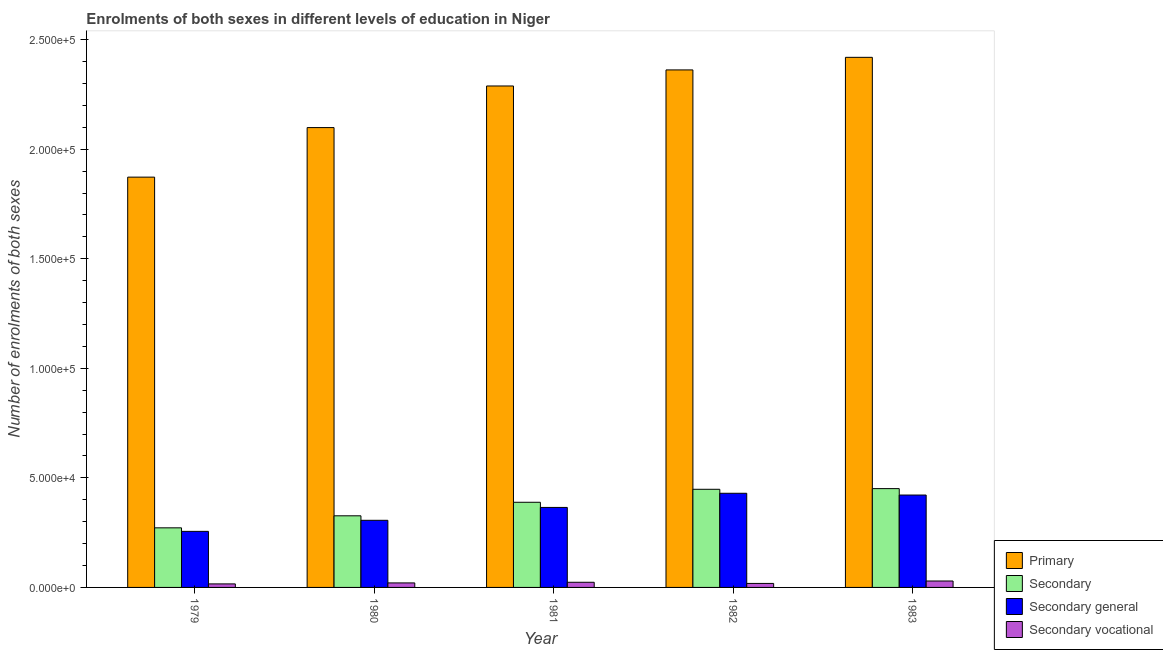How many different coloured bars are there?
Give a very brief answer. 4. How many bars are there on the 5th tick from the left?
Offer a terse response. 4. How many bars are there on the 1st tick from the right?
Make the answer very short. 4. What is the label of the 1st group of bars from the left?
Offer a very short reply. 1979. What is the number of enrolments in primary education in 1983?
Your answer should be very brief. 2.42e+05. Across all years, what is the maximum number of enrolments in secondary general education?
Provide a succinct answer. 4.30e+04. Across all years, what is the minimum number of enrolments in secondary vocational education?
Your response must be concise. 1613. In which year was the number of enrolments in secondary general education minimum?
Provide a short and direct response. 1979. What is the total number of enrolments in primary education in the graph?
Keep it short and to the point. 1.10e+06. What is the difference between the number of enrolments in primary education in 1980 and that in 1981?
Keep it short and to the point. -1.90e+04. What is the difference between the number of enrolments in primary education in 1983 and the number of enrolments in secondary vocational education in 1980?
Your answer should be very brief. 3.21e+04. What is the average number of enrolments in secondary general education per year?
Offer a very short reply. 3.56e+04. What is the ratio of the number of enrolments in secondary general education in 1980 to that in 1981?
Keep it short and to the point. 0.84. Is the number of enrolments in secondary general education in 1980 less than that in 1982?
Ensure brevity in your answer.  Yes. What is the difference between the highest and the second highest number of enrolments in secondary general education?
Your answer should be compact. 803. What is the difference between the highest and the lowest number of enrolments in secondary education?
Make the answer very short. 1.79e+04. In how many years, is the number of enrolments in secondary education greater than the average number of enrolments in secondary education taken over all years?
Make the answer very short. 3. Is it the case that in every year, the sum of the number of enrolments in secondary vocational education and number of enrolments in secondary general education is greater than the sum of number of enrolments in primary education and number of enrolments in secondary education?
Keep it short and to the point. No. What does the 3rd bar from the left in 1981 represents?
Offer a very short reply. Secondary general. What does the 1st bar from the right in 1983 represents?
Give a very brief answer. Secondary vocational. How many years are there in the graph?
Offer a terse response. 5. Does the graph contain any zero values?
Provide a succinct answer. No. What is the title of the graph?
Offer a very short reply. Enrolments of both sexes in different levels of education in Niger. What is the label or title of the Y-axis?
Your response must be concise. Number of enrolments of both sexes. What is the Number of enrolments of both sexes of Primary in 1979?
Keep it short and to the point. 1.87e+05. What is the Number of enrolments of both sexes of Secondary in 1979?
Make the answer very short. 2.72e+04. What is the Number of enrolments of both sexes in Secondary general in 1979?
Keep it short and to the point. 2.56e+04. What is the Number of enrolments of both sexes of Secondary vocational in 1979?
Give a very brief answer. 1613. What is the Number of enrolments of both sexes of Primary in 1980?
Your response must be concise. 2.10e+05. What is the Number of enrolments of both sexes of Secondary in 1980?
Your response must be concise. 3.27e+04. What is the Number of enrolments of both sexes in Secondary general in 1980?
Your response must be concise. 3.06e+04. What is the Number of enrolments of both sexes of Secondary vocational in 1980?
Your answer should be very brief. 2057. What is the Number of enrolments of both sexes of Primary in 1981?
Your answer should be very brief. 2.29e+05. What is the Number of enrolments of both sexes in Secondary in 1981?
Offer a very short reply. 3.89e+04. What is the Number of enrolments of both sexes in Secondary general in 1981?
Offer a terse response. 3.65e+04. What is the Number of enrolments of both sexes in Secondary vocational in 1981?
Give a very brief answer. 2351. What is the Number of enrolments of both sexes in Primary in 1982?
Provide a short and direct response. 2.36e+05. What is the Number of enrolments of both sexes of Secondary in 1982?
Keep it short and to the point. 4.48e+04. What is the Number of enrolments of both sexes of Secondary general in 1982?
Provide a short and direct response. 4.30e+04. What is the Number of enrolments of both sexes of Secondary vocational in 1982?
Keep it short and to the point. 1821. What is the Number of enrolments of both sexes of Primary in 1983?
Offer a very short reply. 2.42e+05. What is the Number of enrolments of both sexes in Secondary in 1983?
Provide a short and direct response. 4.51e+04. What is the Number of enrolments of both sexes in Secondary general in 1983?
Your answer should be very brief. 4.22e+04. What is the Number of enrolments of both sexes of Secondary vocational in 1983?
Provide a succinct answer. 2930. Across all years, what is the maximum Number of enrolments of both sexes of Primary?
Offer a terse response. 2.42e+05. Across all years, what is the maximum Number of enrolments of both sexes in Secondary?
Your answer should be compact. 4.51e+04. Across all years, what is the maximum Number of enrolments of both sexes of Secondary general?
Make the answer very short. 4.30e+04. Across all years, what is the maximum Number of enrolments of both sexes in Secondary vocational?
Make the answer very short. 2930. Across all years, what is the minimum Number of enrolments of both sexes of Primary?
Offer a very short reply. 1.87e+05. Across all years, what is the minimum Number of enrolments of both sexes in Secondary?
Your response must be concise. 2.72e+04. Across all years, what is the minimum Number of enrolments of both sexes in Secondary general?
Give a very brief answer. 2.56e+04. Across all years, what is the minimum Number of enrolments of both sexes in Secondary vocational?
Provide a succinct answer. 1613. What is the total Number of enrolments of both sexes of Primary in the graph?
Your answer should be compact. 1.10e+06. What is the total Number of enrolments of both sexes of Secondary in the graph?
Provide a succinct answer. 1.89e+05. What is the total Number of enrolments of both sexes in Secondary general in the graph?
Keep it short and to the point. 1.78e+05. What is the total Number of enrolments of both sexes of Secondary vocational in the graph?
Ensure brevity in your answer.  1.08e+04. What is the difference between the Number of enrolments of both sexes of Primary in 1979 and that in 1980?
Offer a terse response. -2.26e+04. What is the difference between the Number of enrolments of both sexes of Secondary in 1979 and that in 1980?
Provide a succinct answer. -5491. What is the difference between the Number of enrolments of both sexes of Secondary general in 1979 and that in 1980?
Make the answer very short. -5047. What is the difference between the Number of enrolments of both sexes of Secondary vocational in 1979 and that in 1980?
Your answer should be compact. -444. What is the difference between the Number of enrolments of both sexes in Primary in 1979 and that in 1981?
Your answer should be compact. -4.16e+04. What is the difference between the Number of enrolments of both sexes in Secondary in 1979 and that in 1981?
Your answer should be compact. -1.17e+04. What is the difference between the Number of enrolments of both sexes in Secondary general in 1979 and that in 1981?
Make the answer very short. -1.09e+04. What is the difference between the Number of enrolments of both sexes in Secondary vocational in 1979 and that in 1981?
Your answer should be compact. -738. What is the difference between the Number of enrolments of both sexes in Primary in 1979 and that in 1982?
Your answer should be compact. -4.89e+04. What is the difference between the Number of enrolments of both sexes of Secondary in 1979 and that in 1982?
Offer a very short reply. -1.76e+04. What is the difference between the Number of enrolments of both sexes in Secondary general in 1979 and that in 1982?
Provide a short and direct response. -1.74e+04. What is the difference between the Number of enrolments of both sexes of Secondary vocational in 1979 and that in 1982?
Ensure brevity in your answer.  -208. What is the difference between the Number of enrolments of both sexes in Primary in 1979 and that in 1983?
Your response must be concise. -5.47e+04. What is the difference between the Number of enrolments of both sexes of Secondary in 1979 and that in 1983?
Provide a short and direct response. -1.79e+04. What is the difference between the Number of enrolments of both sexes of Secondary general in 1979 and that in 1983?
Make the answer very short. -1.66e+04. What is the difference between the Number of enrolments of both sexes of Secondary vocational in 1979 and that in 1983?
Your answer should be compact. -1317. What is the difference between the Number of enrolments of both sexes in Primary in 1980 and that in 1981?
Offer a terse response. -1.90e+04. What is the difference between the Number of enrolments of both sexes in Secondary in 1980 and that in 1981?
Your response must be concise. -6174. What is the difference between the Number of enrolments of both sexes in Secondary general in 1980 and that in 1981?
Provide a succinct answer. -5880. What is the difference between the Number of enrolments of both sexes in Secondary vocational in 1980 and that in 1981?
Your answer should be very brief. -294. What is the difference between the Number of enrolments of both sexes of Primary in 1980 and that in 1982?
Ensure brevity in your answer.  -2.63e+04. What is the difference between the Number of enrolments of both sexes in Secondary in 1980 and that in 1982?
Ensure brevity in your answer.  -1.21e+04. What is the difference between the Number of enrolments of both sexes in Secondary general in 1980 and that in 1982?
Keep it short and to the point. -1.23e+04. What is the difference between the Number of enrolments of both sexes of Secondary vocational in 1980 and that in 1982?
Give a very brief answer. 236. What is the difference between the Number of enrolments of both sexes in Primary in 1980 and that in 1983?
Your answer should be compact. -3.21e+04. What is the difference between the Number of enrolments of both sexes in Secondary in 1980 and that in 1983?
Give a very brief answer. -1.24e+04. What is the difference between the Number of enrolments of both sexes of Secondary general in 1980 and that in 1983?
Provide a short and direct response. -1.15e+04. What is the difference between the Number of enrolments of both sexes in Secondary vocational in 1980 and that in 1983?
Make the answer very short. -873. What is the difference between the Number of enrolments of both sexes of Primary in 1981 and that in 1982?
Keep it short and to the point. -7328. What is the difference between the Number of enrolments of both sexes of Secondary in 1981 and that in 1982?
Offer a very short reply. -5927. What is the difference between the Number of enrolments of both sexes in Secondary general in 1981 and that in 1982?
Your response must be concise. -6457. What is the difference between the Number of enrolments of both sexes in Secondary vocational in 1981 and that in 1982?
Give a very brief answer. 530. What is the difference between the Number of enrolments of both sexes in Primary in 1981 and that in 1983?
Make the answer very short. -1.31e+04. What is the difference between the Number of enrolments of both sexes of Secondary in 1981 and that in 1983?
Offer a very short reply. -6233. What is the difference between the Number of enrolments of both sexes in Secondary general in 1981 and that in 1983?
Offer a terse response. -5654. What is the difference between the Number of enrolments of both sexes in Secondary vocational in 1981 and that in 1983?
Keep it short and to the point. -579. What is the difference between the Number of enrolments of both sexes in Primary in 1982 and that in 1983?
Give a very brief answer. -5746. What is the difference between the Number of enrolments of both sexes of Secondary in 1982 and that in 1983?
Your answer should be very brief. -306. What is the difference between the Number of enrolments of both sexes of Secondary general in 1982 and that in 1983?
Offer a very short reply. 803. What is the difference between the Number of enrolments of both sexes of Secondary vocational in 1982 and that in 1983?
Offer a terse response. -1109. What is the difference between the Number of enrolments of both sexes of Primary in 1979 and the Number of enrolments of both sexes of Secondary in 1980?
Your answer should be very brief. 1.55e+05. What is the difference between the Number of enrolments of both sexes in Primary in 1979 and the Number of enrolments of both sexes in Secondary general in 1980?
Offer a terse response. 1.57e+05. What is the difference between the Number of enrolments of both sexes in Primary in 1979 and the Number of enrolments of both sexes in Secondary vocational in 1980?
Offer a terse response. 1.85e+05. What is the difference between the Number of enrolments of both sexes in Secondary in 1979 and the Number of enrolments of both sexes in Secondary general in 1980?
Offer a very short reply. -3434. What is the difference between the Number of enrolments of both sexes in Secondary in 1979 and the Number of enrolments of both sexes in Secondary vocational in 1980?
Your answer should be very brief. 2.51e+04. What is the difference between the Number of enrolments of both sexes in Secondary general in 1979 and the Number of enrolments of both sexes in Secondary vocational in 1980?
Offer a terse response. 2.35e+04. What is the difference between the Number of enrolments of both sexes in Primary in 1979 and the Number of enrolments of both sexes in Secondary in 1981?
Your answer should be compact. 1.48e+05. What is the difference between the Number of enrolments of both sexes in Primary in 1979 and the Number of enrolments of both sexes in Secondary general in 1981?
Your answer should be very brief. 1.51e+05. What is the difference between the Number of enrolments of both sexes in Primary in 1979 and the Number of enrolments of both sexes in Secondary vocational in 1981?
Your answer should be very brief. 1.85e+05. What is the difference between the Number of enrolments of both sexes of Secondary in 1979 and the Number of enrolments of both sexes of Secondary general in 1981?
Offer a terse response. -9314. What is the difference between the Number of enrolments of both sexes of Secondary in 1979 and the Number of enrolments of both sexes of Secondary vocational in 1981?
Offer a terse response. 2.48e+04. What is the difference between the Number of enrolments of both sexes in Secondary general in 1979 and the Number of enrolments of both sexes in Secondary vocational in 1981?
Your answer should be compact. 2.32e+04. What is the difference between the Number of enrolments of both sexes of Primary in 1979 and the Number of enrolments of both sexes of Secondary in 1982?
Ensure brevity in your answer.  1.42e+05. What is the difference between the Number of enrolments of both sexes of Primary in 1979 and the Number of enrolments of both sexes of Secondary general in 1982?
Provide a short and direct response. 1.44e+05. What is the difference between the Number of enrolments of both sexes in Primary in 1979 and the Number of enrolments of both sexes in Secondary vocational in 1982?
Make the answer very short. 1.85e+05. What is the difference between the Number of enrolments of both sexes of Secondary in 1979 and the Number of enrolments of both sexes of Secondary general in 1982?
Provide a succinct answer. -1.58e+04. What is the difference between the Number of enrolments of both sexes in Secondary in 1979 and the Number of enrolments of both sexes in Secondary vocational in 1982?
Offer a very short reply. 2.54e+04. What is the difference between the Number of enrolments of both sexes in Secondary general in 1979 and the Number of enrolments of both sexes in Secondary vocational in 1982?
Offer a terse response. 2.38e+04. What is the difference between the Number of enrolments of both sexes in Primary in 1979 and the Number of enrolments of both sexes in Secondary in 1983?
Your response must be concise. 1.42e+05. What is the difference between the Number of enrolments of both sexes in Primary in 1979 and the Number of enrolments of both sexes in Secondary general in 1983?
Keep it short and to the point. 1.45e+05. What is the difference between the Number of enrolments of both sexes of Primary in 1979 and the Number of enrolments of both sexes of Secondary vocational in 1983?
Ensure brevity in your answer.  1.84e+05. What is the difference between the Number of enrolments of both sexes of Secondary in 1979 and the Number of enrolments of both sexes of Secondary general in 1983?
Provide a succinct answer. -1.50e+04. What is the difference between the Number of enrolments of both sexes of Secondary in 1979 and the Number of enrolments of both sexes of Secondary vocational in 1983?
Provide a succinct answer. 2.43e+04. What is the difference between the Number of enrolments of both sexes in Secondary general in 1979 and the Number of enrolments of both sexes in Secondary vocational in 1983?
Offer a very short reply. 2.27e+04. What is the difference between the Number of enrolments of both sexes in Primary in 1980 and the Number of enrolments of both sexes in Secondary in 1981?
Keep it short and to the point. 1.71e+05. What is the difference between the Number of enrolments of both sexes of Primary in 1980 and the Number of enrolments of both sexes of Secondary general in 1981?
Offer a very short reply. 1.73e+05. What is the difference between the Number of enrolments of both sexes of Primary in 1980 and the Number of enrolments of both sexes of Secondary vocational in 1981?
Give a very brief answer. 2.08e+05. What is the difference between the Number of enrolments of both sexes in Secondary in 1980 and the Number of enrolments of both sexes in Secondary general in 1981?
Your answer should be very brief. -3823. What is the difference between the Number of enrolments of both sexes in Secondary in 1980 and the Number of enrolments of both sexes in Secondary vocational in 1981?
Give a very brief answer. 3.03e+04. What is the difference between the Number of enrolments of both sexes in Secondary general in 1980 and the Number of enrolments of both sexes in Secondary vocational in 1981?
Your response must be concise. 2.83e+04. What is the difference between the Number of enrolments of both sexes in Primary in 1980 and the Number of enrolments of both sexes in Secondary in 1982?
Your answer should be compact. 1.65e+05. What is the difference between the Number of enrolments of both sexes in Primary in 1980 and the Number of enrolments of both sexes in Secondary general in 1982?
Provide a succinct answer. 1.67e+05. What is the difference between the Number of enrolments of both sexes in Primary in 1980 and the Number of enrolments of both sexes in Secondary vocational in 1982?
Ensure brevity in your answer.  2.08e+05. What is the difference between the Number of enrolments of both sexes of Secondary in 1980 and the Number of enrolments of both sexes of Secondary general in 1982?
Offer a very short reply. -1.03e+04. What is the difference between the Number of enrolments of both sexes of Secondary in 1980 and the Number of enrolments of both sexes of Secondary vocational in 1982?
Offer a terse response. 3.09e+04. What is the difference between the Number of enrolments of both sexes in Secondary general in 1980 and the Number of enrolments of both sexes in Secondary vocational in 1982?
Offer a terse response. 2.88e+04. What is the difference between the Number of enrolments of both sexes in Primary in 1980 and the Number of enrolments of both sexes in Secondary in 1983?
Make the answer very short. 1.65e+05. What is the difference between the Number of enrolments of both sexes of Primary in 1980 and the Number of enrolments of both sexes of Secondary general in 1983?
Offer a terse response. 1.68e+05. What is the difference between the Number of enrolments of both sexes of Primary in 1980 and the Number of enrolments of both sexes of Secondary vocational in 1983?
Ensure brevity in your answer.  2.07e+05. What is the difference between the Number of enrolments of both sexes in Secondary in 1980 and the Number of enrolments of both sexes in Secondary general in 1983?
Keep it short and to the point. -9477. What is the difference between the Number of enrolments of both sexes of Secondary in 1980 and the Number of enrolments of both sexes of Secondary vocational in 1983?
Make the answer very short. 2.98e+04. What is the difference between the Number of enrolments of both sexes of Secondary general in 1980 and the Number of enrolments of both sexes of Secondary vocational in 1983?
Make the answer very short. 2.77e+04. What is the difference between the Number of enrolments of both sexes in Primary in 1981 and the Number of enrolments of both sexes in Secondary in 1982?
Your answer should be compact. 1.84e+05. What is the difference between the Number of enrolments of both sexes of Primary in 1981 and the Number of enrolments of both sexes of Secondary general in 1982?
Keep it short and to the point. 1.86e+05. What is the difference between the Number of enrolments of both sexes in Primary in 1981 and the Number of enrolments of both sexes in Secondary vocational in 1982?
Your answer should be compact. 2.27e+05. What is the difference between the Number of enrolments of both sexes in Secondary in 1981 and the Number of enrolments of both sexes in Secondary general in 1982?
Keep it short and to the point. -4106. What is the difference between the Number of enrolments of both sexes in Secondary in 1981 and the Number of enrolments of both sexes in Secondary vocational in 1982?
Make the answer very short. 3.70e+04. What is the difference between the Number of enrolments of both sexes in Secondary general in 1981 and the Number of enrolments of both sexes in Secondary vocational in 1982?
Provide a short and direct response. 3.47e+04. What is the difference between the Number of enrolments of both sexes in Primary in 1981 and the Number of enrolments of both sexes in Secondary in 1983?
Your response must be concise. 1.84e+05. What is the difference between the Number of enrolments of both sexes in Primary in 1981 and the Number of enrolments of both sexes in Secondary general in 1983?
Offer a very short reply. 1.87e+05. What is the difference between the Number of enrolments of both sexes in Primary in 1981 and the Number of enrolments of both sexes in Secondary vocational in 1983?
Make the answer very short. 2.26e+05. What is the difference between the Number of enrolments of both sexes in Secondary in 1981 and the Number of enrolments of both sexes in Secondary general in 1983?
Keep it short and to the point. -3303. What is the difference between the Number of enrolments of both sexes of Secondary in 1981 and the Number of enrolments of both sexes of Secondary vocational in 1983?
Keep it short and to the point. 3.59e+04. What is the difference between the Number of enrolments of both sexes in Secondary general in 1981 and the Number of enrolments of both sexes in Secondary vocational in 1983?
Make the answer very short. 3.36e+04. What is the difference between the Number of enrolments of both sexes in Primary in 1982 and the Number of enrolments of both sexes in Secondary in 1983?
Provide a short and direct response. 1.91e+05. What is the difference between the Number of enrolments of both sexes of Primary in 1982 and the Number of enrolments of both sexes of Secondary general in 1983?
Provide a succinct answer. 1.94e+05. What is the difference between the Number of enrolments of both sexes of Primary in 1982 and the Number of enrolments of both sexes of Secondary vocational in 1983?
Offer a terse response. 2.33e+05. What is the difference between the Number of enrolments of both sexes of Secondary in 1982 and the Number of enrolments of both sexes of Secondary general in 1983?
Your answer should be very brief. 2624. What is the difference between the Number of enrolments of both sexes of Secondary in 1982 and the Number of enrolments of both sexes of Secondary vocational in 1983?
Keep it short and to the point. 4.19e+04. What is the difference between the Number of enrolments of both sexes of Secondary general in 1982 and the Number of enrolments of both sexes of Secondary vocational in 1983?
Provide a short and direct response. 4.00e+04. What is the average Number of enrolments of both sexes in Primary per year?
Keep it short and to the point. 2.21e+05. What is the average Number of enrolments of both sexes in Secondary per year?
Offer a very short reply. 3.77e+04. What is the average Number of enrolments of both sexes of Secondary general per year?
Provide a short and direct response. 3.56e+04. What is the average Number of enrolments of both sexes in Secondary vocational per year?
Offer a terse response. 2154.4. In the year 1979, what is the difference between the Number of enrolments of both sexes in Primary and Number of enrolments of both sexes in Secondary?
Give a very brief answer. 1.60e+05. In the year 1979, what is the difference between the Number of enrolments of both sexes of Primary and Number of enrolments of both sexes of Secondary general?
Offer a terse response. 1.62e+05. In the year 1979, what is the difference between the Number of enrolments of both sexes of Primary and Number of enrolments of both sexes of Secondary vocational?
Ensure brevity in your answer.  1.86e+05. In the year 1979, what is the difference between the Number of enrolments of both sexes in Secondary and Number of enrolments of both sexes in Secondary general?
Offer a terse response. 1613. In the year 1979, what is the difference between the Number of enrolments of both sexes in Secondary and Number of enrolments of both sexes in Secondary vocational?
Provide a succinct answer. 2.56e+04. In the year 1979, what is the difference between the Number of enrolments of both sexes in Secondary general and Number of enrolments of both sexes in Secondary vocational?
Your answer should be compact. 2.40e+04. In the year 1980, what is the difference between the Number of enrolments of both sexes of Primary and Number of enrolments of both sexes of Secondary?
Keep it short and to the point. 1.77e+05. In the year 1980, what is the difference between the Number of enrolments of both sexes of Primary and Number of enrolments of both sexes of Secondary general?
Your answer should be compact. 1.79e+05. In the year 1980, what is the difference between the Number of enrolments of both sexes in Primary and Number of enrolments of both sexes in Secondary vocational?
Keep it short and to the point. 2.08e+05. In the year 1980, what is the difference between the Number of enrolments of both sexes in Secondary and Number of enrolments of both sexes in Secondary general?
Give a very brief answer. 2057. In the year 1980, what is the difference between the Number of enrolments of both sexes of Secondary and Number of enrolments of both sexes of Secondary vocational?
Your answer should be very brief. 3.06e+04. In the year 1980, what is the difference between the Number of enrolments of both sexes in Secondary general and Number of enrolments of both sexes in Secondary vocational?
Make the answer very short. 2.86e+04. In the year 1981, what is the difference between the Number of enrolments of both sexes in Primary and Number of enrolments of both sexes in Secondary?
Give a very brief answer. 1.90e+05. In the year 1981, what is the difference between the Number of enrolments of both sexes of Primary and Number of enrolments of both sexes of Secondary general?
Offer a very short reply. 1.92e+05. In the year 1981, what is the difference between the Number of enrolments of both sexes in Primary and Number of enrolments of both sexes in Secondary vocational?
Offer a terse response. 2.27e+05. In the year 1981, what is the difference between the Number of enrolments of both sexes in Secondary and Number of enrolments of both sexes in Secondary general?
Ensure brevity in your answer.  2351. In the year 1981, what is the difference between the Number of enrolments of both sexes in Secondary and Number of enrolments of both sexes in Secondary vocational?
Your answer should be very brief. 3.65e+04. In the year 1981, what is the difference between the Number of enrolments of both sexes in Secondary general and Number of enrolments of both sexes in Secondary vocational?
Keep it short and to the point. 3.42e+04. In the year 1982, what is the difference between the Number of enrolments of both sexes in Primary and Number of enrolments of both sexes in Secondary?
Give a very brief answer. 1.91e+05. In the year 1982, what is the difference between the Number of enrolments of both sexes of Primary and Number of enrolments of both sexes of Secondary general?
Your answer should be compact. 1.93e+05. In the year 1982, what is the difference between the Number of enrolments of both sexes in Primary and Number of enrolments of both sexes in Secondary vocational?
Your answer should be very brief. 2.34e+05. In the year 1982, what is the difference between the Number of enrolments of both sexes in Secondary and Number of enrolments of both sexes in Secondary general?
Offer a very short reply. 1821. In the year 1982, what is the difference between the Number of enrolments of both sexes in Secondary and Number of enrolments of both sexes in Secondary vocational?
Ensure brevity in your answer.  4.30e+04. In the year 1982, what is the difference between the Number of enrolments of both sexes in Secondary general and Number of enrolments of both sexes in Secondary vocational?
Provide a short and direct response. 4.11e+04. In the year 1983, what is the difference between the Number of enrolments of both sexes of Primary and Number of enrolments of both sexes of Secondary?
Your answer should be very brief. 1.97e+05. In the year 1983, what is the difference between the Number of enrolments of both sexes in Primary and Number of enrolments of both sexes in Secondary general?
Your answer should be compact. 2.00e+05. In the year 1983, what is the difference between the Number of enrolments of both sexes of Primary and Number of enrolments of both sexes of Secondary vocational?
Your answer should be compact. 2.39e+05. In the year 1983, what is the difference between the Number of enrolments of both sexes in Secondary and Number of enrolments of both sexes in Secondary general?
Provide a succinct answer. 2930. In the year 1983, what is the difference between the Number of enrolments of both sexes in Secondary and Number of enrolments of both sexes in Secondary vocational?
Provide a succinct answer. 4.22e+04. In the year 1983, what is the difference between the Number of enrolments of both sexes of Secondary general and Number of enrolments of both sexes of Secondary vocational?
Give a very brief answer. 3.92e+04. What is the ratio of the Number of enrolments of both sexes in Primary in 1979 to that in 1980?
Ensure brevity in your answer.  0.89. What is the ratio of the Number of enrolments of both sexes of Secondary in 1979 to that in 1980?
Make the answer very short. 0.83. What is the ratio of the Number of enrolments of both sexes in Secondary general in 1979 to that in 1980?
Keep it short and to the point. 0.84. What is the ratio of the Number of enrolments of both sexes in Secondary vocational in 1979 to that in 1980?
Provide a short and direct response. 0.78. What is the ratio of the Number of enrolments of both sexes in Primary in 1979 to that in 1981?
Your answer should be very brief. 0.82. What is the ratio of the Number of enrolments of both sexes of Secondary in 1979 to that in 1981?
Give a very brief answer. 0.7. What is the ratio of the Number of enrolments of both sexes in Secondary general in 1979 to that in 1981?
Keep it short and to the point. 0.7. What is the ratio of the Number of enrolments of both sexes in Secondary vocational in 1979 to that in 1981?
Ensure brevity in your answer.  0.69. What is the ratio of the Number of enrolments of both sexes in Primary in 1979 to that in 1982?
Offer a very short reply. 0.79. What is the ratio of the Number of enrolments of both sexes of Secondary in 1979 to that in 1982?
Your answer should be very brief. 0.61. What is the ratio of the Number of enrolments of both sexes in Secondary general in 1979 to that in 1982?
Offer a very short reply. 0.6. What is the ratio of the Number of enrolments of both sexes in Secondary vocational in 1979 to that in 1982?
Ensure brevity in your answer.  0.89. What is the ratio of the Number of enrolments of both sexes of Primary in 1979 to that in 1983?
Keep it short and to the point. 0.77. What is the ratio of the Number of enrolments of both sexes of Secondary in 1979 to that in 1983?
Offer a terse response. 0.6. What is the ratio of the Number of enrolments of both sexes in Secondary general in 1979 to that in 1983?
Offer a very short reply. 0.61. What is the ratio of the Number of enrolments of both sexes in Secondary vocational in 1979 to that in 1983?
Ensure brevity in your answer.  0.55. What is the ratio of the Number of enrolments of both sexes of Primary in 1980 to that in 1981?
Offer a very short reply. 0.92. What is the ratio of the Number of enrolments of both sexes of Secondary in 1980 to that in 1981?
Your response must be concise. 0.84. What is the ratio of the Number of enrolments of both sexes of Secondary general in 1980 to that in 1981?
Give a very brief answer. 0.84. What is the ratio of the Number of enrolments of both sexes of Secondary vocational in 1980 to that in 1981?
Offer a very short reply. 0.87. What is the ratio of the Number of enrolments of both sexes in Primary in 1980 to that in 1982?
Offer a terse response. 0.89. What is the ratio of the Number of enrolments of both sexes in Secondary in 1980 to that in 1982?
Your answer should be very brief. 0.73. What is the ratio of the Number of enrolments of both sexes in Secondary general in 1980 to that in 1982?
Offer a very short reply. 0.71. What is the ratio of the Number of enrolments of both sexes of Secondary vocational in 1980 to that in 1982?
Offer a very short reply. 1.13. What is the ratio of the Number of enrolments of both sexes in Primary in 1980 to that in 1983?
Offer a terse response. 0.87. What is the ratio of the Number of enrolments of both sexes of Secondary in 1980 to that in 1983?
Your response must be concise. 0.72. What is the ratio of the Number of enrolments of both sexes of Secondary general in 1980 to that in 1983?
Ensure brevity in your answer.  0.73. What is the ratio of the Number of enrolments of both sexes in Secondary vocational in 1980 to that in 1983?
Provide a short and direct response. 0.7. What is the ratio of the Number of enrolments of both sexes in Primary in 1981 to that in 1982?
Give a very brief answer. 0.97. What is the ratio of the Number of enrolments of both sexes of Secondary in 1981 to that in 1982?
Your answer should be very brief. 0.87. What is the ratio of the Number of enrolments of both sexes of Secondary general in 1981 to that in 1982?
Provide a short and direct response. 0.85. What is the ratio of the Number of enrolments of both sexes in Secondary vocational in 1981 to that in 1982?
Ensure brevity in your answer.  1.29. What is the ratio of the Number of enrolments of both sexes in Primary in 1981 to that in 1983?
Offer a very short reply. 0.95. What is the ratio of the Number of enrolments of both sexes in Secondary in 1981 to that in 1983?
Offer a very short reply. 0.86. What is the ratio of the Number of enrolments of both sexes of Secondary general in 1981 to that in 1983?
Keep it short and to the point. 0.87. What is the ratio of the Number of enrolments of both sexes in Secondary vocational in 1981 to that in 1983?
Offer a terse response. 0.8. What is the ratio of the Number of enrolments of both sexes in Primary in 1982 to that in 1983?
Make the answer very short. 0.98. What is the ratio of the Number of enrolments of both sexes of Secondary general in 1982 to that in 1983?
Keep it short and to the point. 1.02. What is the ratio of the Number of enrolments of both sexes of Secondary vocational in 1982 to that in 1983?
Your answer should be very brief. 0.62. What is the difference between the highest and the second highest Number of enrolments of both sexes in Primary?
Provide a succinct answer. 5746. What is the difference between the highest and the second highest Number of enrolments of both sexes of Secondary?
Offer a terse response. 306. What is the difference between the highest and the second highest Number of enrolments of both sexes of Secondary general?
Provide a succinct answer. 803. What is the difference between the highest and the second highest Number of enrolments of both sexes in Secondary vocational?
Your answer should be compact. 579. What is the difference between the highest and the lowest Number of enrolments of both sexes in Primary?
Offer a terse response. 5.47e+04. What is the difference between the highest and the lowest Number of enrolments of both sexes of Secondary?
Your answer should be compact. 1.79e+04. What is the difference between the highest and the lowest Number of enrolments of both sexes of Secondary general?
Provide a succinct answer. 1.74e+04. What is the difference between the highest and the lowest Number of enrolments of both sexes in Secondary vocational?
Your answer should be very brief. 1317. 